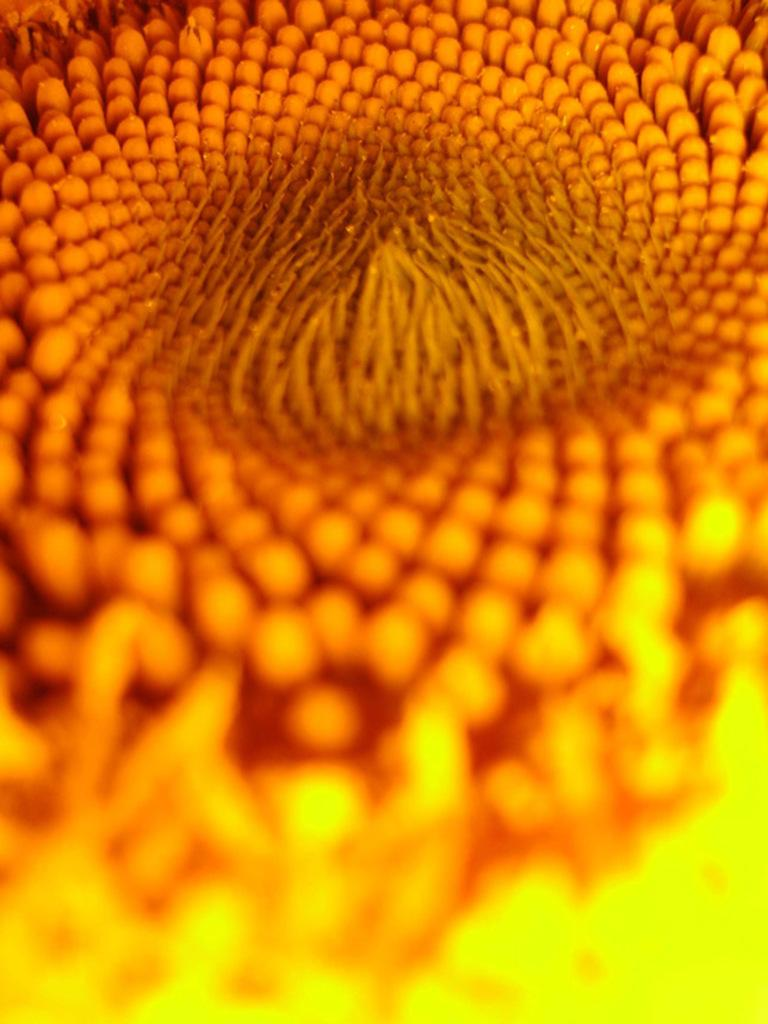What is the main subject of the image? The main subject of the image is a flower. Can you describe the flower in the image? The image is a close-up picture of the flower, so we can see its petals, stamen, and other details. What type of apparel is the flower wearing in the image? Flowers do not wear apparel, so this question cannot be answered. 